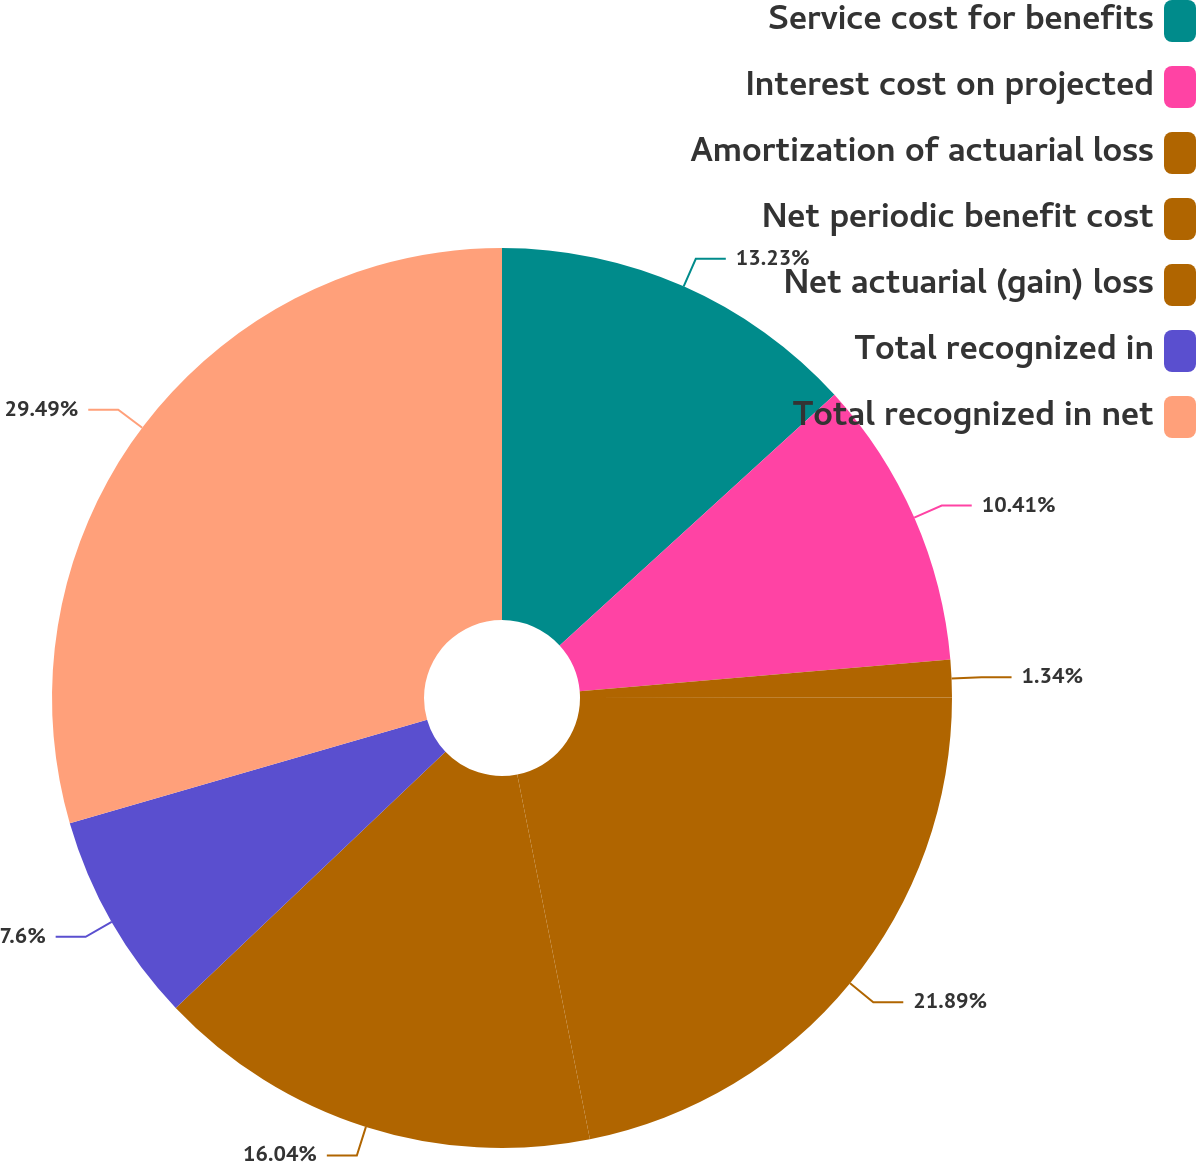Convert chart to OTSL. <chart><loc_0><loc_0><loc_500><loc_500><pie_chart><fcel>Service cost for benefits<fcel>Interest cost on projected<fcel>Amortization of actuarial loss<fcel>Net periodic benefit cost<fcel>Net actuarial (gain) loss<fcel>Total recognized in<fcel>Total recognized in net<nl><fcel>13.23%<fcel>10.41%<fcel>1.34%<fcel>21.89%<fcel>16.04%<fcel>7.6%<fcel>29.49%<nl></chart> 